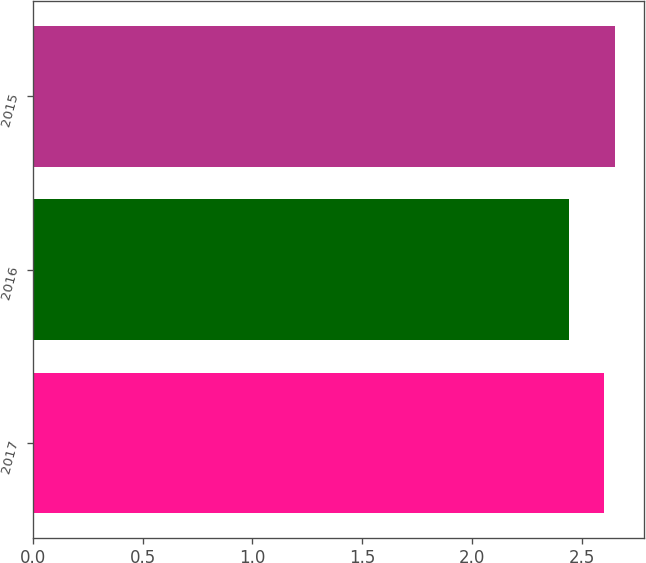Convert chart. <chart><loc_0><loc_0><loc_500><loc_500><bar_chart><fcel>2017<fcel>2016<fcel>2015<nl><fcel>2.6<fcel>2.44<fcel>2.65<nl></chart> 